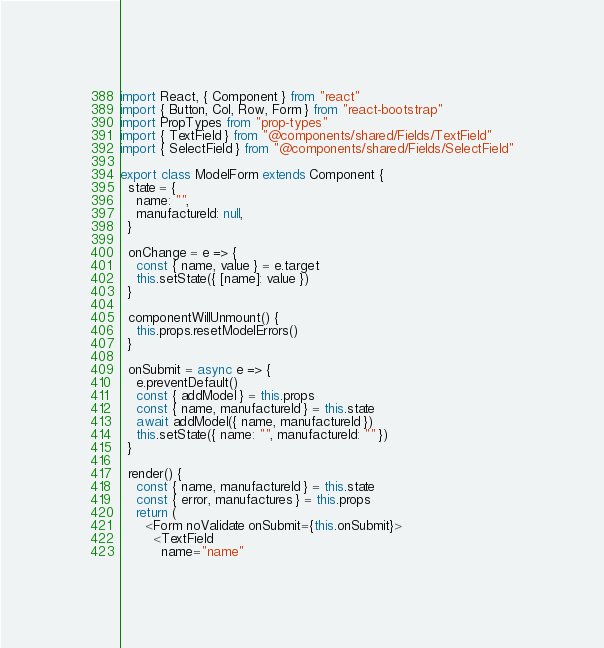Convert code to text. <code><loc_0><loc_0><loc_500><loc_500><_JavaScript_>import React, { Component } from "react"
import { Button, Col, Row, Form } from "react-bootstrap"
import PropTypes from "prop-types"
import { TextField } from "@components/shared/Fields/TextField"
import { SelectField } from "@components/shared/Fields/SelectField"

export class ModelForm extends Component {
  state = {
    name: "",
    manufactureId: null,
  }

  onChange = e => {
    const { name, value } = e.target
    this.setState({ [name]: value })
  }

  componentWillUnmount() {
    this.props.resetModelErrors()
  }

  onSubmit = async e => {
    e.preventDefault()
    const { addModel } = this.props
    const { name, manufactureId } = this.state
    await addModel({ name, manufactureId })
    this.setState({ name: "", manufactureId: "" })
  }

  render() {
    const { name, manufactureId } = this.state
    const { error, manufactures } = this.props
    return (
      <Form noValidate onSubmit={this.onSubmit}>
        <TextField
          name="name"</code> 